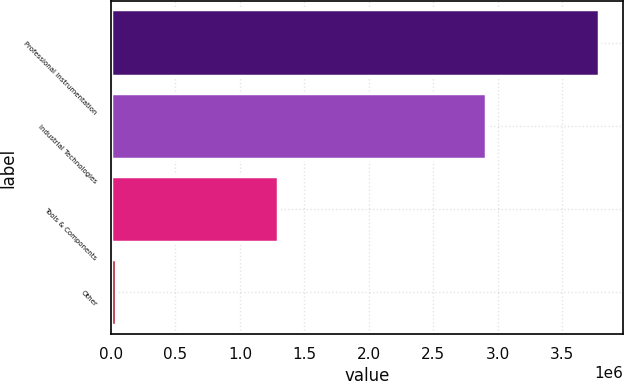Convert chart. <chart><loc_0><loc_0><loc_500><loc_500><bar_chart><fcel>Professional Instrumentation<fcel>Industrial Technologies<fcel>Tools & Components<fcel>Other<nl><fcel>3.78211e+06<fcel>2.90814e+06<fcel>1.29445e+06<fcel>38014<nl></chart> 